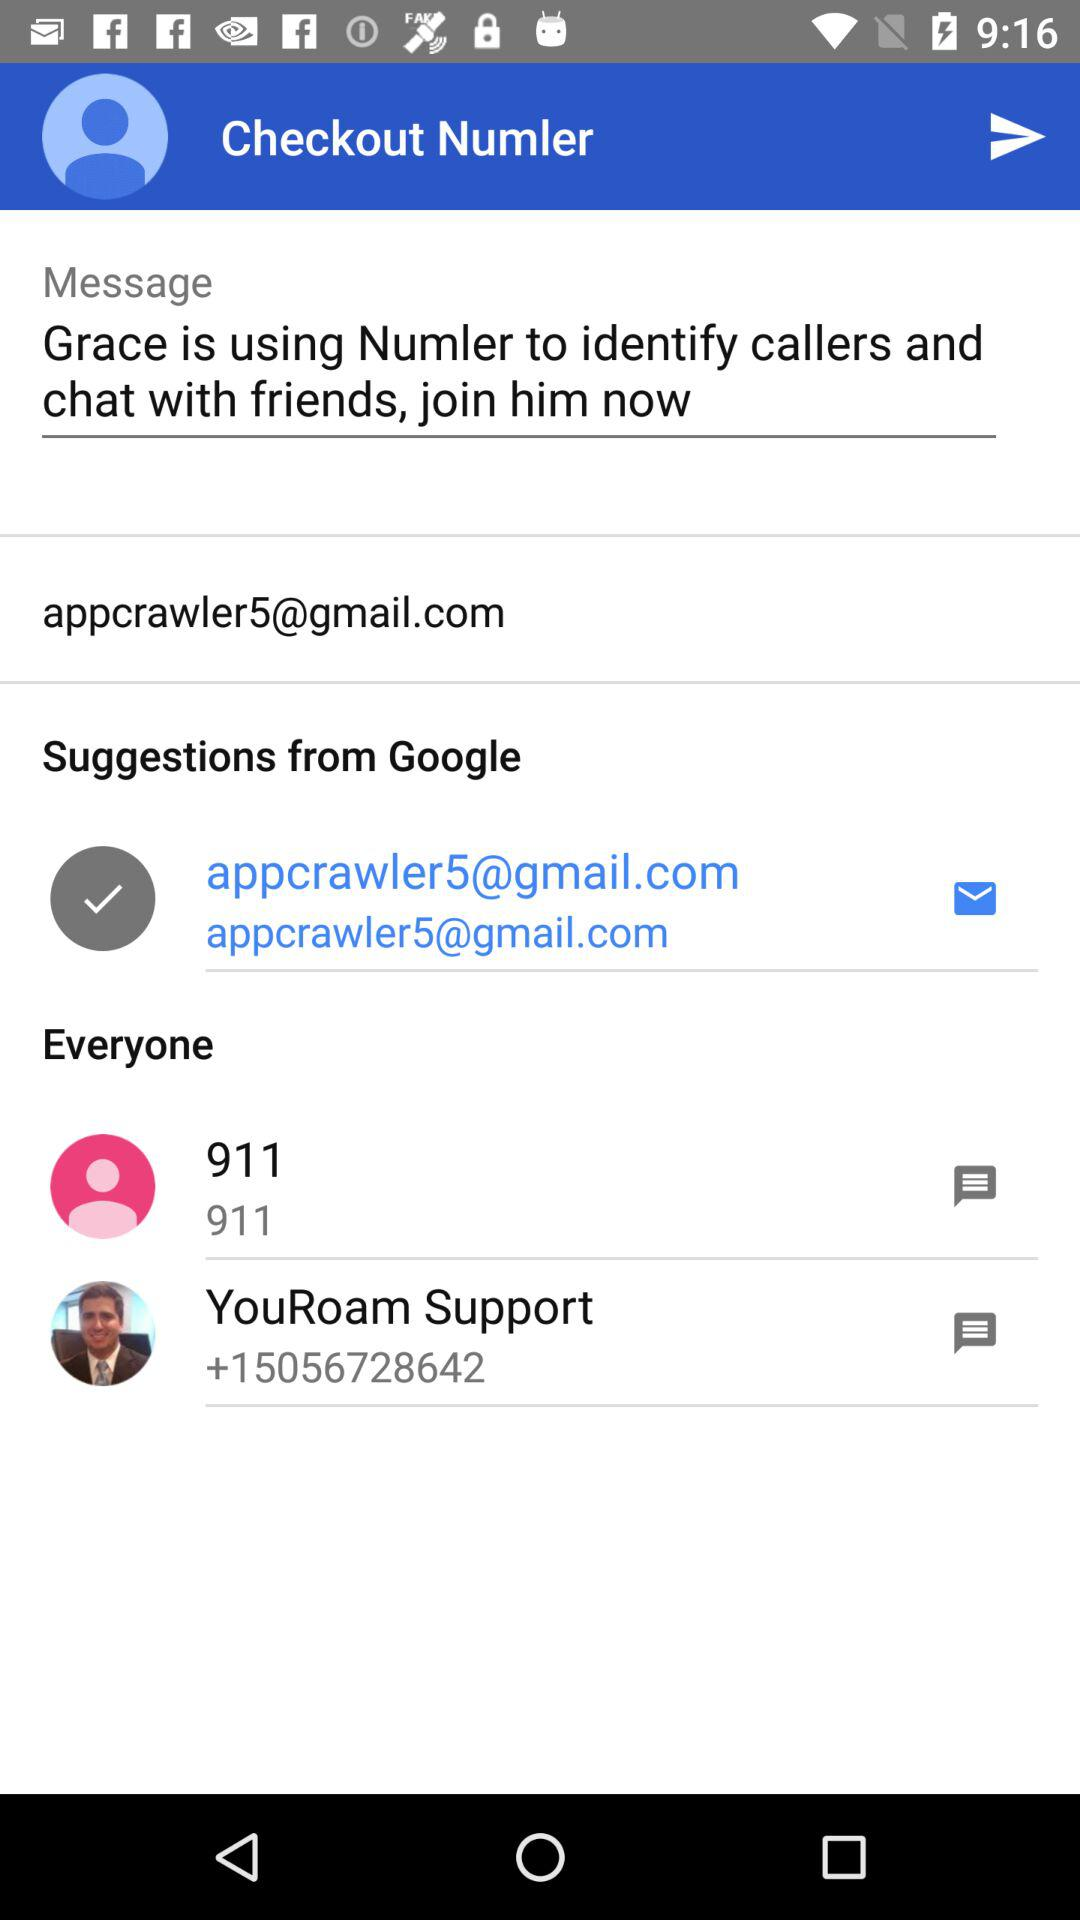What is the Gmail account address? The Gmail account address is appcrawler5@gmail.com. 